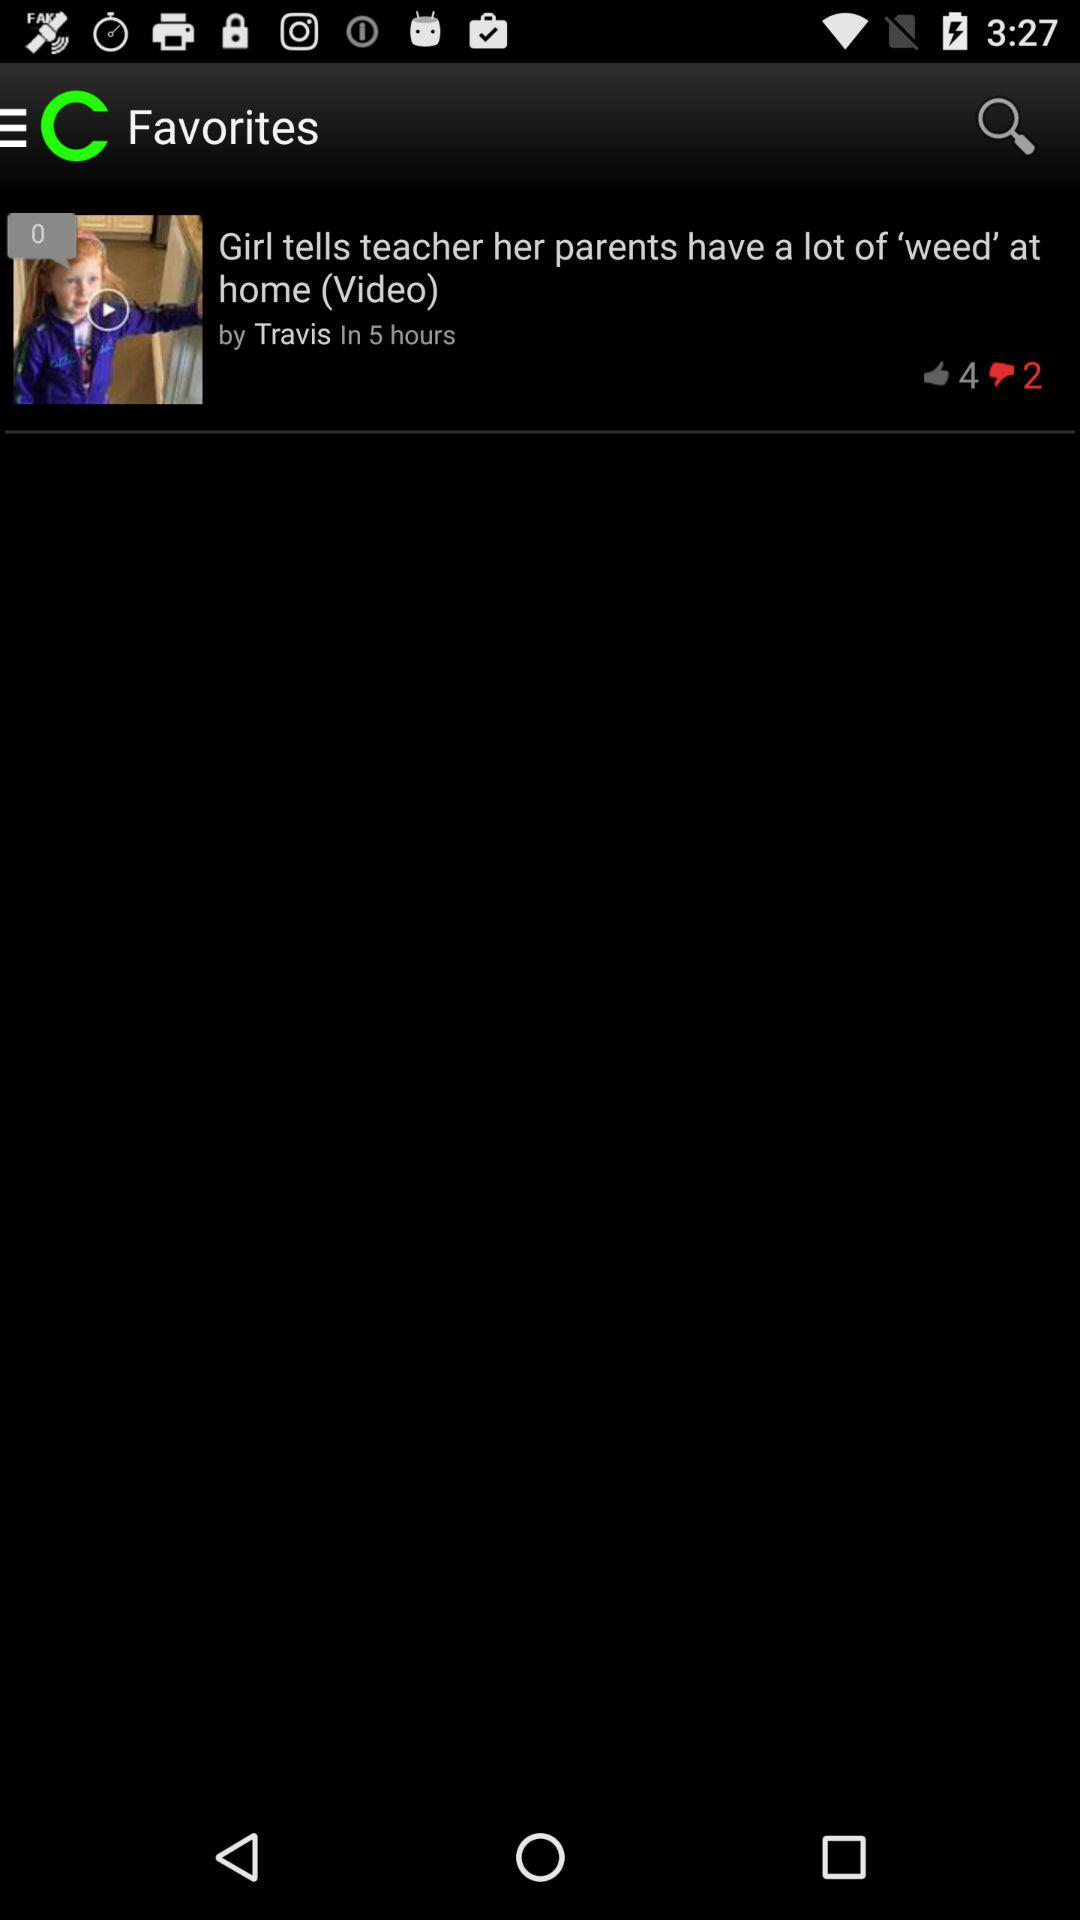How many likes did the video get that was uploaded by Travis? There are 4 likes on the video that was uploaded by Travis. 